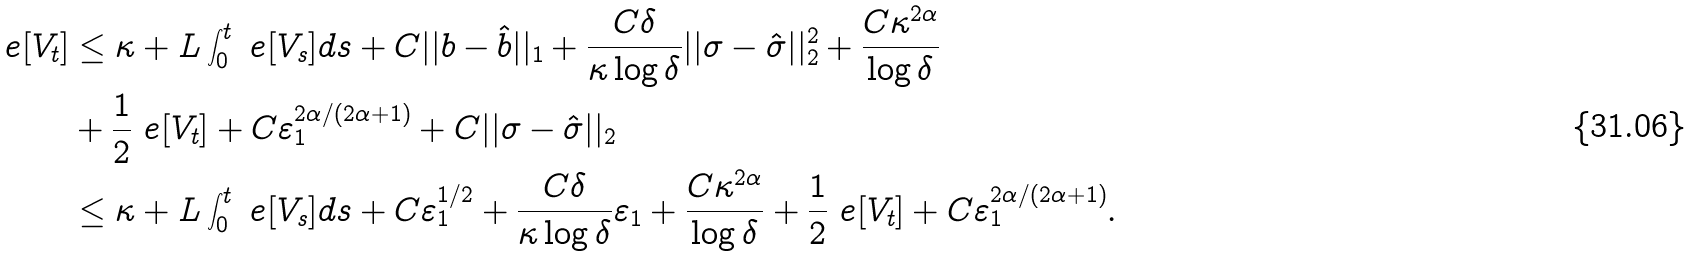<formula> <loc_0><loc_0><loc_500><loc_500>\ e [ V _ { t } ] & \leq \kappa + L \int _ { 0 } ^ { t } \ e [ V _ { s } ] d s + C | | b - \hat { b } | | _ { 1 } + \frac { C \delta } { \kappa \log \delta } | | \sigma - \hat { \sigma } | | _ { 2 } ^ { 2 } + \frac { C \kappa ^ { 2 \alpha } } { \log \delta } \\ & + \frac { 1 } { 2 } \ e [ V _ { t } ] + C \varepsilon _ { 1 } ^ { 2 \alpha / ( 2 \alpha + 1 ) } + C | | \sigma - \hat { \sigma } | | _ { 2 } \\ & \leq \kappa + L \int _ { 0 } ^ { t } \ e [ V _ { s } ] d s + C \varepsilon _ { 1 } ^ { 1 / 2 } + \frac { C \delta } { \kappa \log \delta } \varepsilon _ { 1 } + \frac { C \kappa ^ { 2 \alpha } } { \log \delta } + \frac { 1 } { 2 } \ e [ V _ { t } ] + C \varepsilon _ { 1 } ^ { 2 \alpha / ( 2 \alpha + 1 ) } .</formula> 